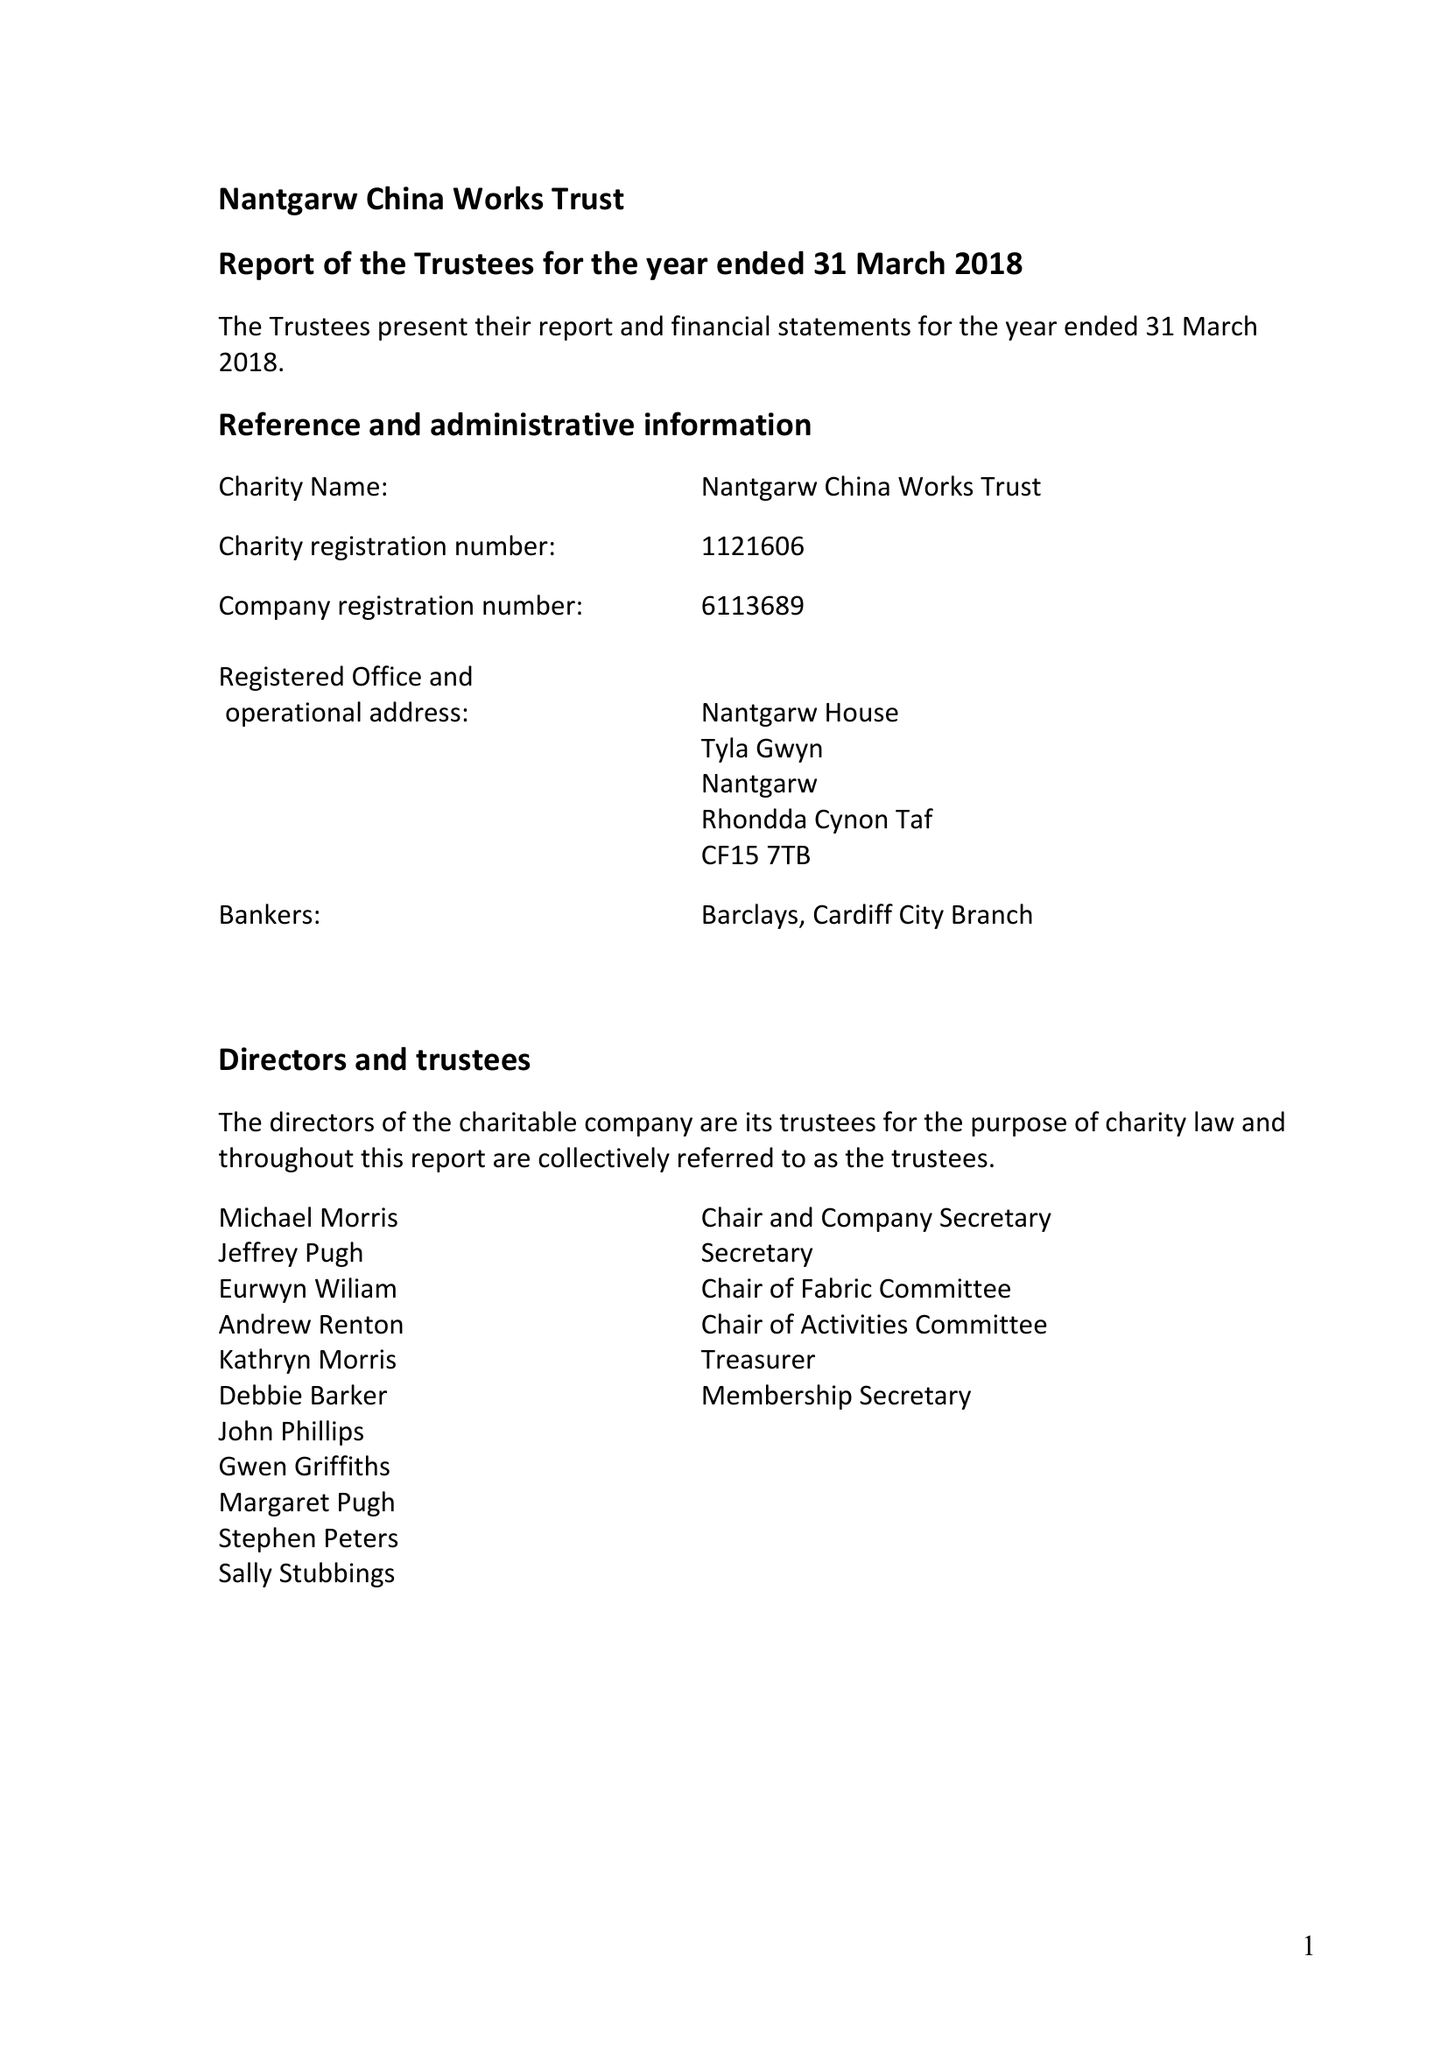What is the value for the address__post_town?
Answer the question using a single word or phrase. CARDIFF 